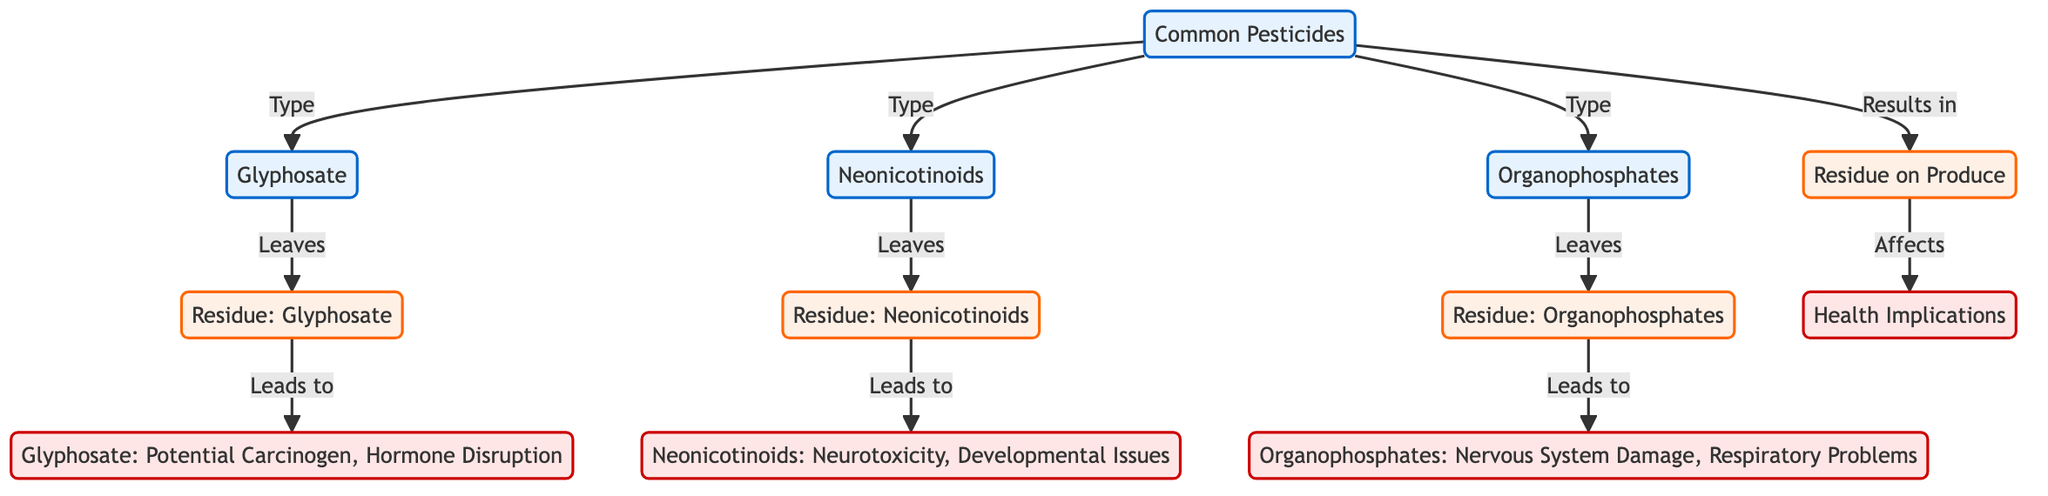What are the three types of common pesticides listed? The diagram identifies three types of common pesticides: Glyphosate, Neonicotinoids, and Organophosphates. These can be found branching out from the "Common Pesticides" node in the diagram.
Answer: Glyphosate, Neonicotinoids, Organophosphates Which pesticide is associated with potential carcinogenic effects? The diagram shows that Glyphosate is the pesticide associated with potential carcinogenic effects, as indicated under the health implications connected to Glyphosate residue.
Answer: Glyphosate What health implication is linked to Neonicotinoids? According to the diagram, Neonicotinoids are linked to neurotoxicity and developmental issues, as indicated in the health implications section connected to Neonicotinoids residue.
Answer: Neurotoxicity, Developmental Issues How many types of pesticide residues are mentioned in the diagram? The diagram mentions three types of pesticide residues, which are tied to the respective pesticides: Glyphosate residue, Neonicotinoid residue, and Organophosphate residue. This can be counted from the nodes under "Residue on Produce."
Answer: 3 What is the primary health effect associated with Organophosphates? The primary health effect associated with Organophosphates, as shown in the diagram, is Nervous System Damage and Respiratory Problems, which appear in the health implications connected to Organophosphate residue.
Answer: Nervous System Damage, Respiratory Problems If Glyphosate and Organophosphates are both used, what happens regarding health implications? The diagram indicates that both Glyphosate and Organophosphates lead to specific health implications via their residues. Glyphosate residue results in potential carcinogenic effects, while Organophosphate residue leads to nervous system damage and respiratory problems. Thus, if both pesticides are used, the potential health risks would include a combination of those effects.
Answer: Both health implications apply What are the implications of pesticide residue on health? The implications of pesticide residue on health include potential carcinogenic effects, neurotoxicity, developmental issues, and nervous system damage as outlined in the health implications section connected to each type of pesticide residue. These implications capture the risks presented by consuming produce with pesticide residue.
Answer: Multiple health implications Which pesticide leads to the residue affecting human health? The diagram shows that all three types of pesticides—Glyphosate, Neonicotinoids, and Organophosphates—lead to residues affecting human health. Each pesticide is directly connected to its respective residue, which in turn affects health.
Answer: All three pesticides 